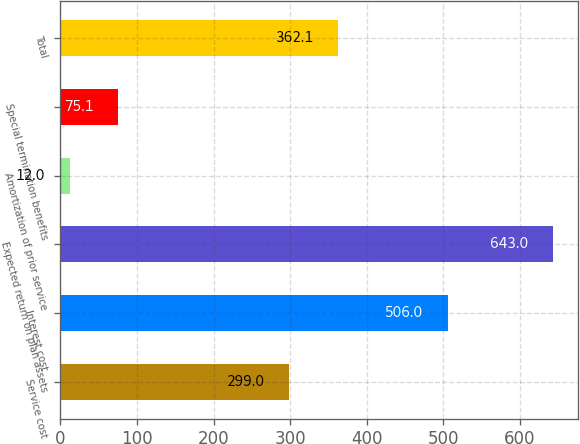<chart> <loc_0><loc_0><loc_500><loc_500><bar_chart><fcel>Service cost<fcel>Interest cost<fcel>Expected return on plan assets<fcel>Amortization of prior service<fcel>Special termination benefits<fcel>Total<nl><fcel>299<fcel>506<fcel>643<fcel>12<fcel>75.1<fcel>362.1<nl></chart> 